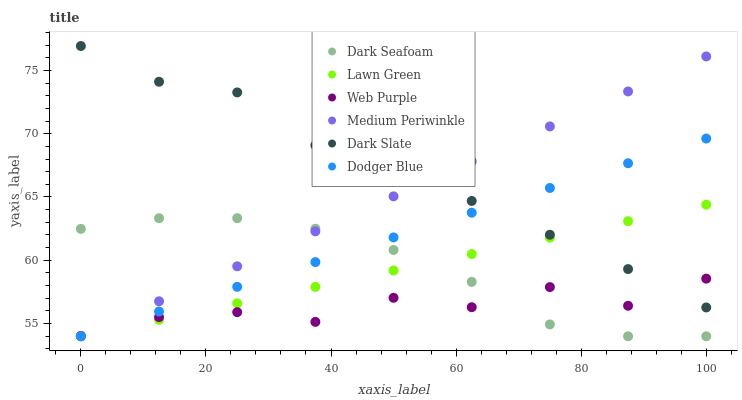Does Web Purple have the minimum area under the curve?
Answer yes or no. Yes. Does Dark Slate have the maximum area under the curve?
Answer yes or no. Yes. Does Medium Periwinkle have the minimum area under the curve?
Answer yes or no. No. Does Medium Periwinkle have the maximum area under the curve?
Answer yes or no. No. Is Dodger Blue the smoothest?
Answer yes or no. Yes. Is Web Purple the roughest?
Answer yes or no. Yes. Is Medium Periwinkle the smoothest?
Answer yes or no. No. Is Medium Periwinkle the roughest?
Answer yes or no. No. Does Lawn Green have the lowest value?
Answer yes or no. Yes. Does Web Purple have the lowest value?
Answer yes or no. No. Does Dark Slate have the highest value?
Answer yes or no. Yes. Does Medium Periwinkle have the highest value?
Answer yes or no. No. Is Dark Seafoam less than Dark Slate?
Answer yes or no. Yes. Is Dark Slate greater than Dark Seafoam?
Answer yes or no. Yes. Does Medium Periwinkle intersect Dodger Blue?
Answer yes or no. Yes. Is Medium Periwinkle less than Dodger Blue?
Answer yes or no. No. Is Medium Periwinkle greater than Dodger Blue?
Answer yes or no. No. Does Dark Seafoam intersect Dark Slate?
Answer yes or no. No. 